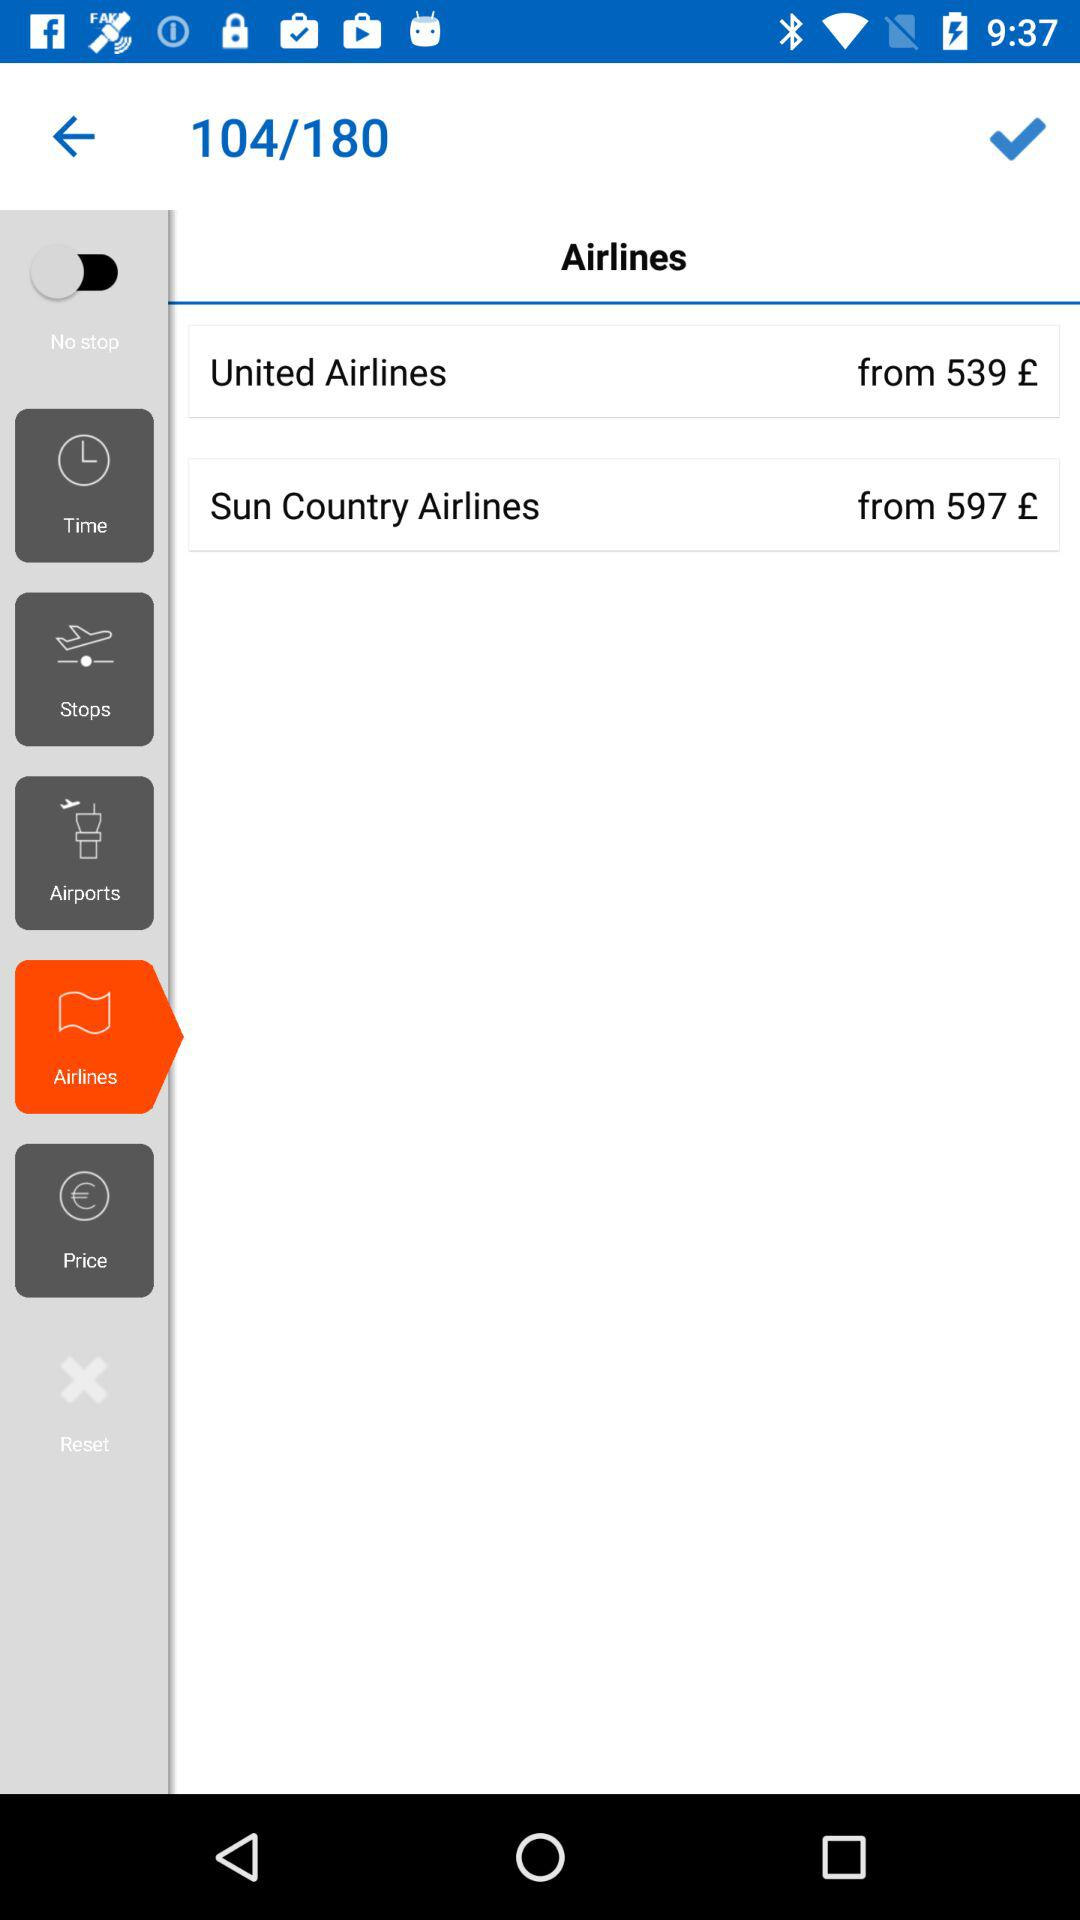What's the starting price for "United Airlines"? The starting price for "United Airlines" is 539 £. 